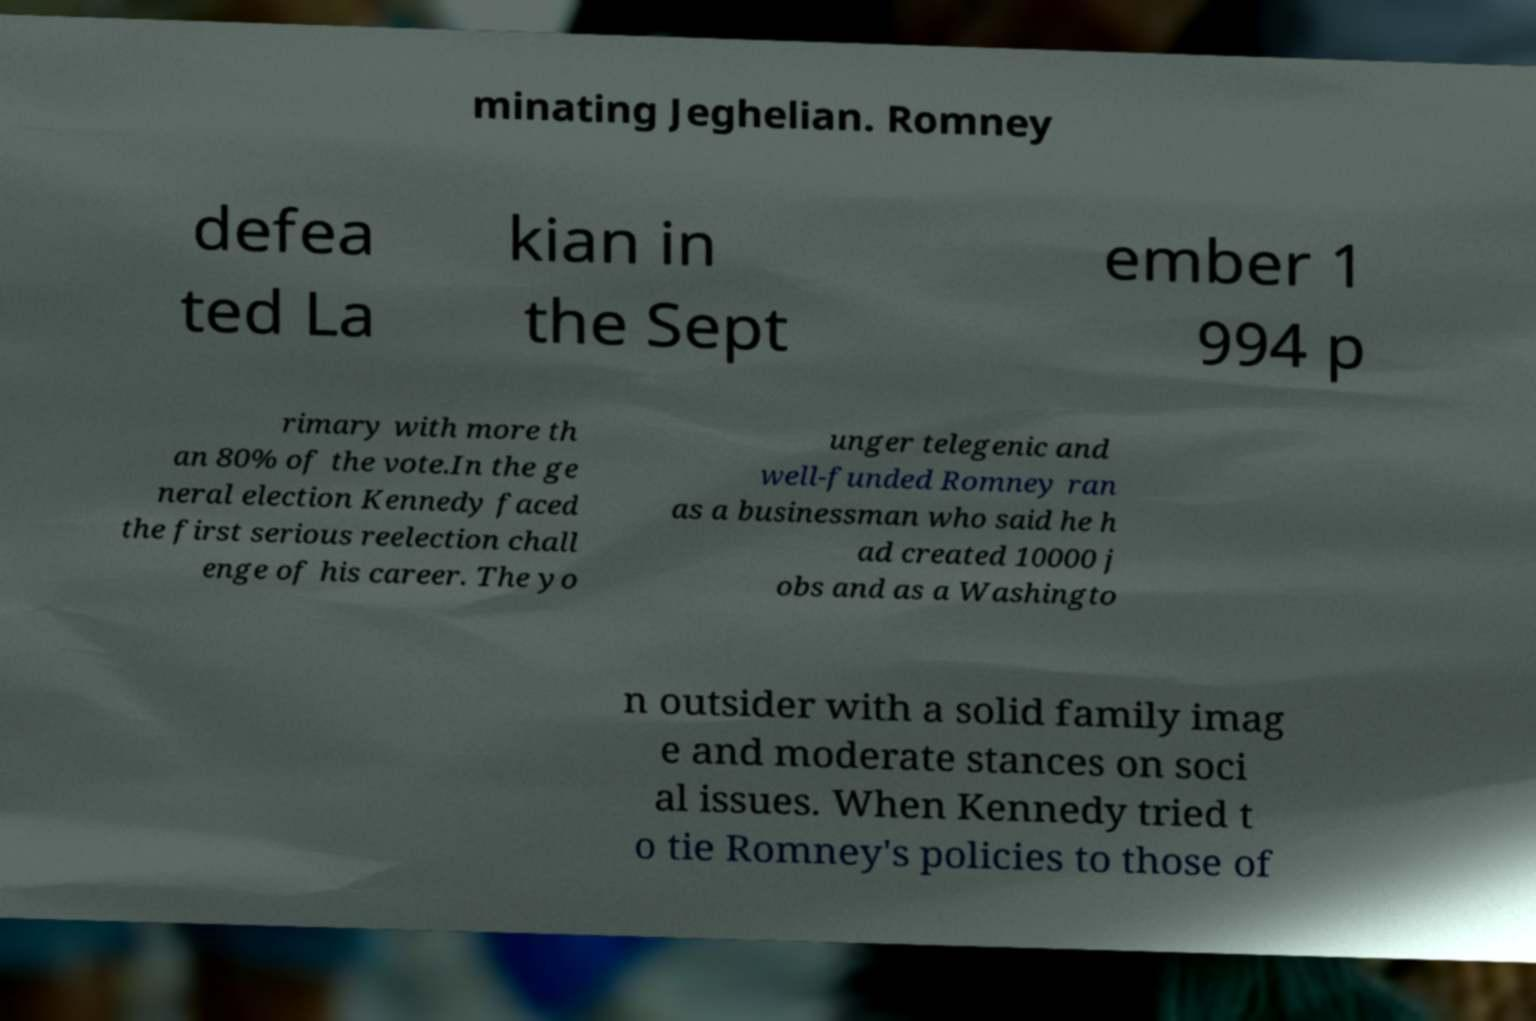Could you assist in decoding the text presented in this image and type it out clearly? minating Jeghelian. Romney defea ted La kian in the Sept ember 1 994 p rimary with more th an 80% of the vote.In the ge neral election Kennedy faced the first serious reelection chall enge of his career. The yo unger telegenic and well-funded Romney ran as a businessman who said he h ad created 10000 j obs and as a Washingto n outsider with a solid family imag e and moderate stances on soci al issues. When Kennedy tried t o tie Romney's policies to those of 